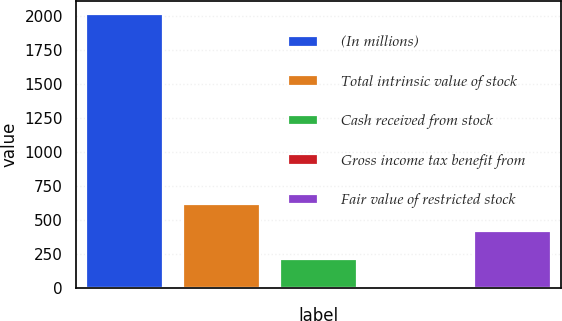Convert chart. <chart><loc_0><loc_0><loc_500><loc_500><bar_chart><fcel>(In millions)<fcel>Total intrinsic value of stock<fcel>Cash received from stock<fcel>Gross income tax benefit from<fcel>Fair value of restricted stock<nl><fcel>2014<fcel>615.4<fcel>215.8<fcel>16<fcel>415.6<nl></chart> 